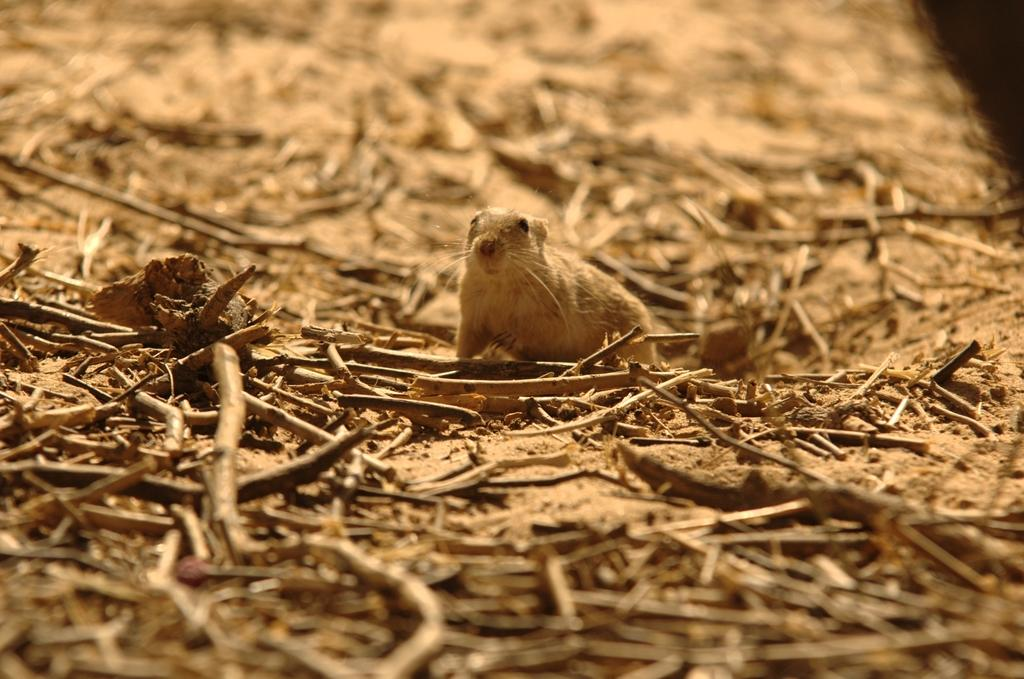What is the main subject in the center of the image? There is an animal in the center of the image. What can be seen at the bottom of the image? There are twigs at the bottom of the image. What type of bomb is the animal holding in the image? There is no bomb present in the image; it only features an animal and twigs. Can you tell me how many grandmothers are in the image? There are no grandmothers present in the image; it only features an animal and twigs. 